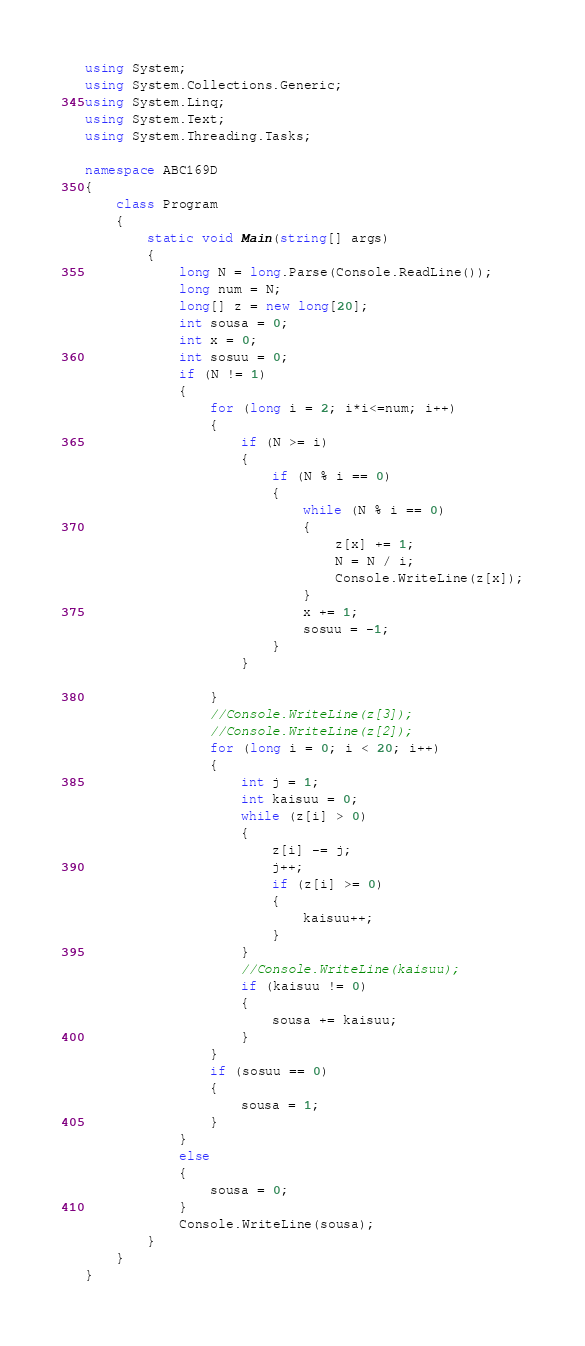<code> <loc_0><loc_0><loc_500><loc_500><_C#_>using System;
using System.Collections.Generic;
using System.Linq;
using System.Text;
using System.Threading.Tasks;

namespace ABC169D
{
    class Program
    {
        static void Main(string[] args)
        {
            long N = long.Parse(Console.ReadLine());
            long num = N;
            long[] z = new long[20];
            int sousa = 0;
            int x = 0;
            int sosuu = 0;
            if (N != 1)
            {
                for (long i = 2; i*i<=num; i++)
                {
                    if (N >= i)
                    {
                        if (N % i == 0)
                        {
                            while (N % i == 0)
                            {
                                z[x] += 1;
                                N = N / i;
                                Console.WriteLine(z[x]);
                            }
                            x += 1;
                            sosuu = -1;
                        }
                    }

                }
                //Console.WriteLine(z[3]);
                //Console.WriteLine(z[2]);
                for (long i = 0; i < 20; i++)
                {
                    int j = 1;
                    int kaisuu = 0;
                    while (z[i] > 0)
                    {
                        z[i] -= j;
                        j++;
                        if (z[i] >= 0)
                        {
                            kaisuu++;
                        }
                    }
                    //Console.WriteLine(kaisuu);
                    if (kaisuu != 0)
                    {
                        sousa += kaisuu;
                    }
                }
                if (sosuu == 0)
                {
                    sousa = 1;
                }
            }
            else
            {
                sousa = 0;
            }
            Console.WriteLine(sousa);
        }
    }
}
</code> 